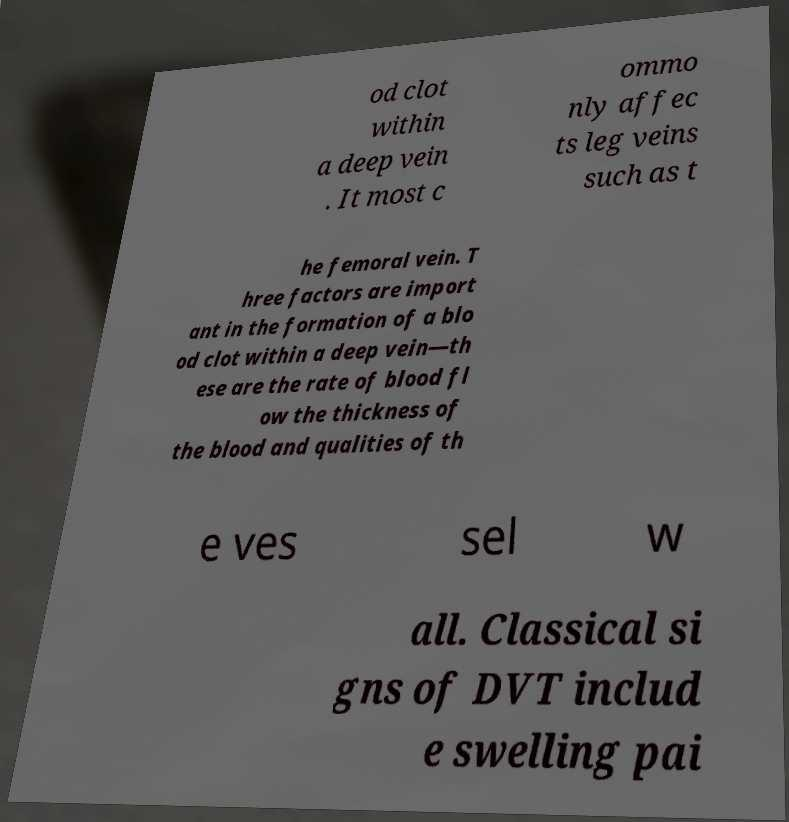Can you read and provide the text displayed in the image?This photo seems to have some interesting text. Can you extract and type it out for me? od clot within a deep vein . It most c ommo nly affec ts leg veins such as t he femoral vein. T hree factors are import ant in the formation of a blo od clot within a deep vein—th ese are the rate of blood fl ow the thickness of the blood and qualities of th e ves sel w all. Classical si gns of DVT includ e swelling pai 